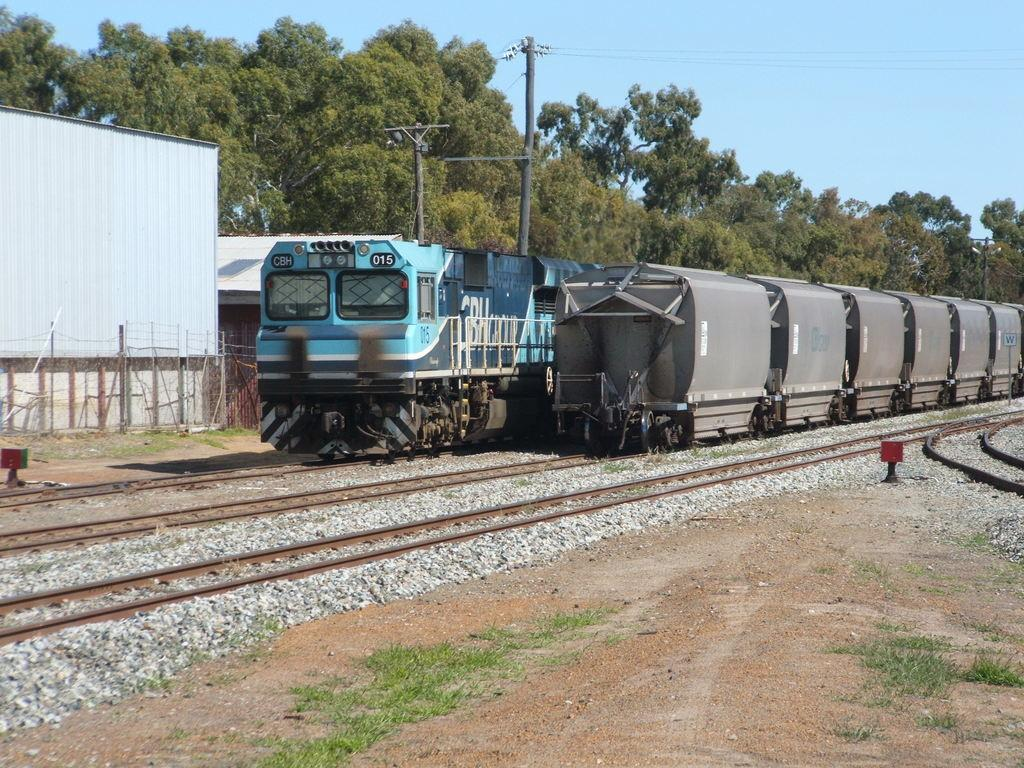How many trains are visible in the image? There are two trains in the image. Are the trains on the same track or separate tracks? The trains are on separate tracks. What can be seen in the background of the image? There are buildings, trees, and poles in the backdrop of the image. What is the condition of the sky in the image? The sky is clear in the image. What type of pie is being served on the train in the image? There is no pie visible in the image, nor is there any indication that food is being served on the train. 